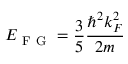Convert formula to latex. <formula><loc_0><loc_0><loc_500><loc_500>E _ { F G } = \frac { 3 } { 5 } \frac { \hbar { ^ } { 2 } k _ { F } ^ { 2 } } { 2 m }</formula> 